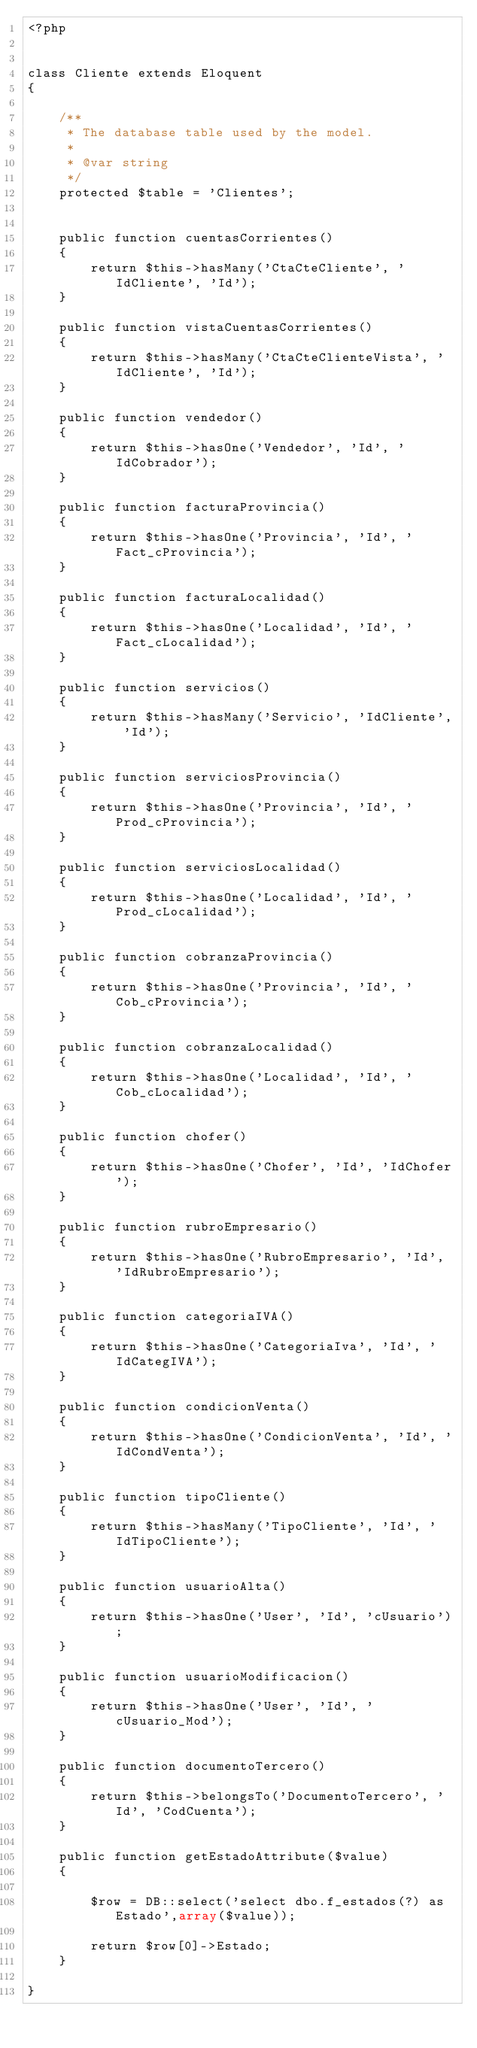Convert code to text. <code><loc_0><loc_0><loc_500><loc_500><_PHP_><?php


class Cliente extends Eloquent
{

    /**
     * The database table used by the model.
     *
     * @var string
     */
    protected $table = 'Clientes';


    public function cuentasCorrientes()
    {
        return $this->hasMany('CtaCteCliente', 'IdCliente', 'Id');
    }

    public function vistaCuentasCorrientes()
    {
        return $this->hasMany('CtaCteClienteVista', 'IdCliente', 'Id');
    }

    public function vendedor()
    {
        return $this->hasOne('Vendedor', 'Id', 'IdCobrador');
    }

    public function facturaProvincia()
    {
        return $this->hasOne('Provincia', 'Id', 'Fact_cProvincia');
    }

    public function facturaLocalidad()
    {
        return $this->hasOne('Localidad', 'Id', 'Fact_cLocalidad');
    }

    public function servicios()
    {
        return $this->hasMany('Servicio', 'IdCliente', 'Id');
    }

    public function serviciosProvincia()
    {
        return $this->hasOne('Provincia', 'Id', 'Prod_cProvincia');
    }

    public function serviciosLocalidad()
    {
        return $this->hasOne('Localidad', 'Id', 'Prod_cLocalidad');
    }

    public function cobranzaProvincia()
    {
        return $this->hasOne('Provincia', 'Id', 'Cob_cProvincia');
    }

    public function cobranzaLocalidad()
    {
        return $this->hasOne('Localidad', 'Id', 'Cob_cLocalidad');
    }

    public function chofer()
    {
        return $this->hasOne('Chofer', 'Id', 'IdChofer');
    }

    public function rubroEmpresario()
    {
        return $this->hasOne('RubroEmpresario', 'Id', 'IdRubroEmpresario');
    }

    public function categoriaIVA()
    {
        return $this->hasOne('CategoriaIva', 'Id', 'IdCategIVA');
    }

    public function condicionVenta()
    {
        return $this->hasOne('CondicionVenta', 'Id', 'IdCondVenta');
    }

    public function tipoCliente()
    {
        return $this->hasMany('TipoCliente', 'Id', 'IdTipoCliente');
    }

    public function usuarioAlta()
    {
        return $this->hasOne('User', 'Id', 'cUsuario');
    }

    public function usuarioModificacion()
    {
        return $this->hasOne('User', 'Id', 'cUsuario_Mod');
    }

    public function documentoTercero()
    {
        return $this->belongsTo('DocumentoTercero', 'Id', 'CodCuenta');
    }

    public function getEstadoAttribute($value)
    {

        $row = DB::select('select dbo.f_estados(?) as Estado',array($value));

        return $row[0]->Estado;
    }

}
</code> 